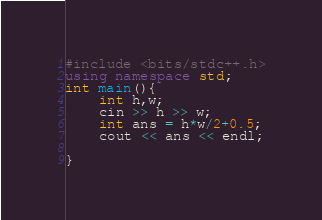<code> <loc_0><loc_0><loc_500><loc_500><_C++_>#include <bits/stdc++.h>
using namespace std;
int main(){
	int h,w;
	cin >> h >> w;
	int ans = h*w/2+0.5;
	cout << ans << endl;

}</code> 